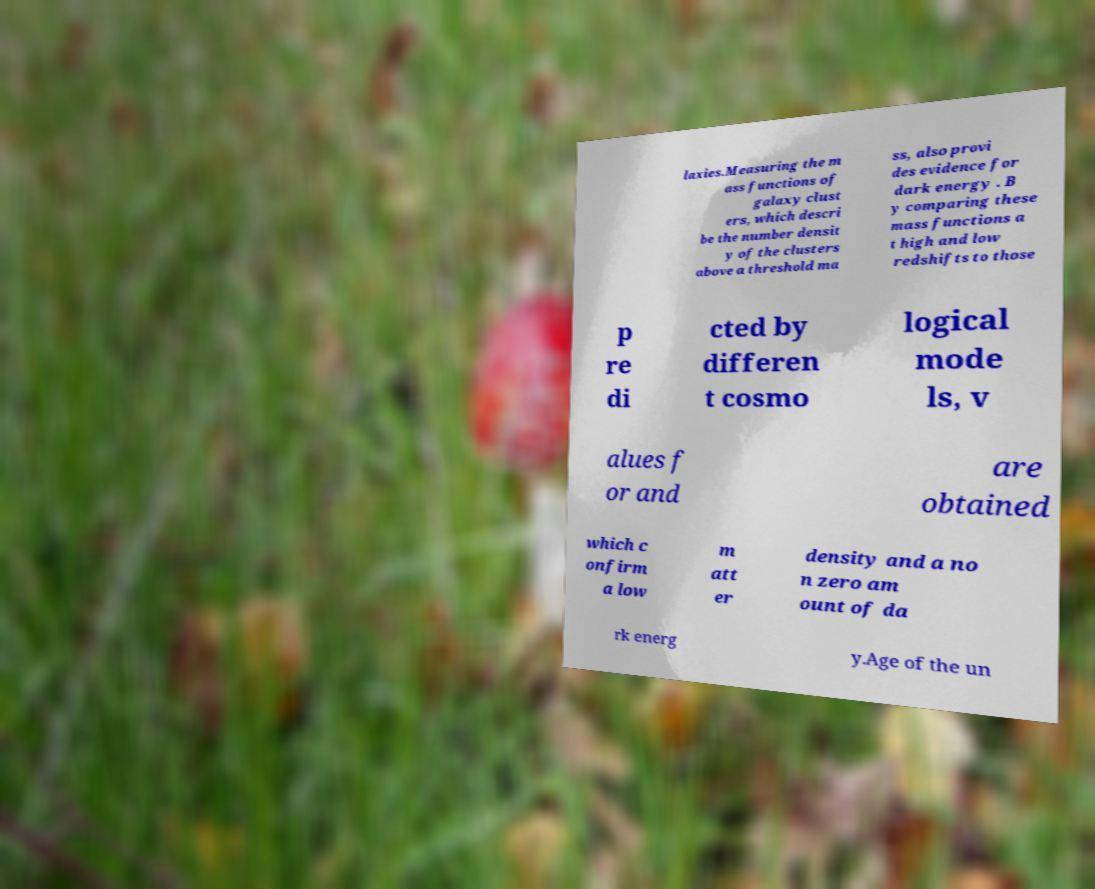For documentation purposes, I need the text within this image transcribed. Could you provide that? laxies.Measuring the m ass functions of galaxy clust ers, which descri be the number densit y of the clusters above a threshold ma ss, also provi des evidence for dark energy . B y comparing these mass functions a t high and low redshifts to those p re di cted by differen t cosmo logical mode ls, v alues f or and are obtained which c onfirm a low m att er density and a no n zero am ount of da rk energ y.Age of the un 